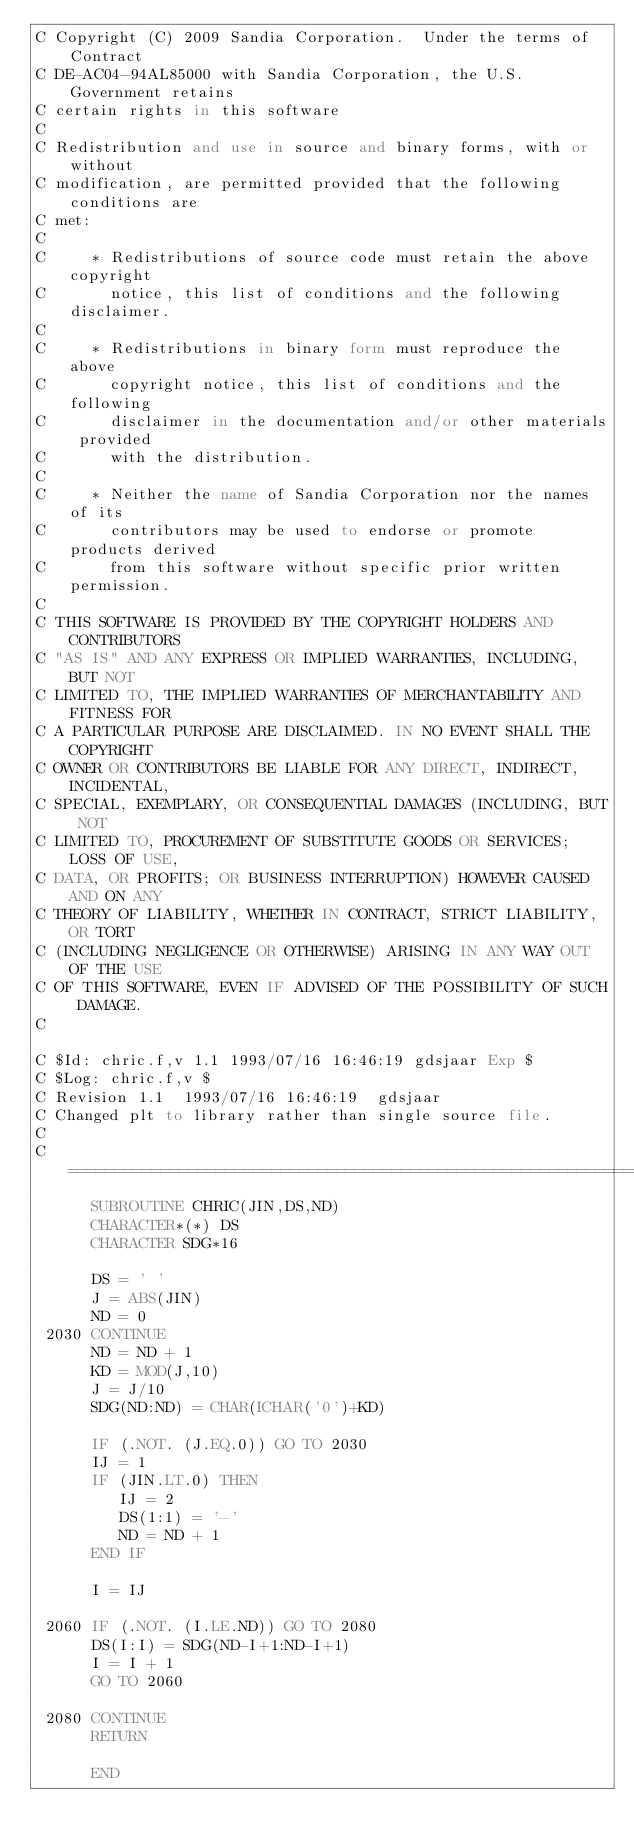<code> <loc_0><loc_0><loc_500><loc_500><_FORTRAN_>C Copyright (C) 2009 Sandia Corporation.  Under the terms of Contract
C DE-AC04-94AL85000 with Sandia Corporation, the U.S. Government retains
C certain rights in this software
C 
C Redistribution and use in source and binary forms, with or without
C modification, are permitted provided that the following conditions are
C met:
C 
C     * Redistributions of source code must retain the above copyright
C       notice, this list of conditions and the following disclaimer.
C 
C     * Redistributions in binary form must reproduce the above
C       copyright notice, this list of conditions and the following
C       disclaimer in the documentation and/or other materials provided
C       with the distribution.
C 
C     * Neither the name of Sandia Corporation nor the names of its
C       contributors may be used to endorse or promote products derived
C       from this software without specific prior written permission.
C 
C THIS SOFTWARE IS PROVIDED BY THE COPYRIGHT HOLDERS AND CONTRIBUTORS
C "AS IS" AND ANY EXPRESS OR IMPLIED WARRANTIES, INCLUDING, BUT NOT
C LIMITED TO, THE IMPLIED WARRANTIES OF MERCHANTABILITY AND FITNESS FOR
C A PARTICULAR PURPOSE ARE DISCLAIMED. IN NO EVENT SHALL THE COPYRIGHT
C OWNER OR CONTRIBUTORS BE LIABLE FOR ANY DIRECT, INDIRECT, INCIDENTAL,
C SPECIAL, EXEMPLARY, OR CONSEQUENTIAL DAMAGES (INCLUDING, BUT NOT
C LIMITED TO, PROCUREMENT OF SUBSTITUTE GOODS OR SERVICES; LOSS OF USE,
C DATA, OR PROFITS; OR BUSINESS INTERRUPTION) HOWEVER CAUSED AND ON ANY
C THEORY OF LIABILITY, WHETHER IN CONTRACT, STRICT LIABILITY, OR TORT
C (INCLUDING NEGLIGENCE OR OTHERWISE) ARISING IN ANY WAY OUT OF THE USE
C OF THIS SOFTWARE, EVEN IF ADVISED OF THE POSSIBILITY OF SUCH DAMAGE.
C 

C $Id: chric.f,v 1.1 1993/07/16 16:46:19 gdsjaar Exp $ 
C $Log: chric.f,v $
C Revision 1.1  1993/07/16 16:46:19  gdsjaar
C Changed plt to library rather than single source file.
C 
C=======================================================================
      SUBROUTINE CHRIC(JIN,DS,ND)
      CHARACTER*(*) DS
      CHARACTER SDG*16

      DS = ' '
      J = ABS(JIN)
      ND = 0
 2030 CONTINUE
      ND = ND + 1
      KD = MOD(J,10)
      J = J/10
      SDG(ND:ND) = CHAR(ICHAR('0')+KD)

      IF (.NOT. (J.EQ.0)) GO TO 2030
      IJ = 1
      IF (JIN.LT.0) THEN
         IJ = 2
         DS(1:1) = '-'
         ND = ND + 1
      END IF

      I = IJ

 2060 IF (.NOT. (I.LE.ND)) GO TO 2080
      DS(I:I) = SDG(ND-I+1:ND-I+1)
      I = I + 1
      GO TO 2060

 2080 CONTINUE
      RETURN

      END
</code> 